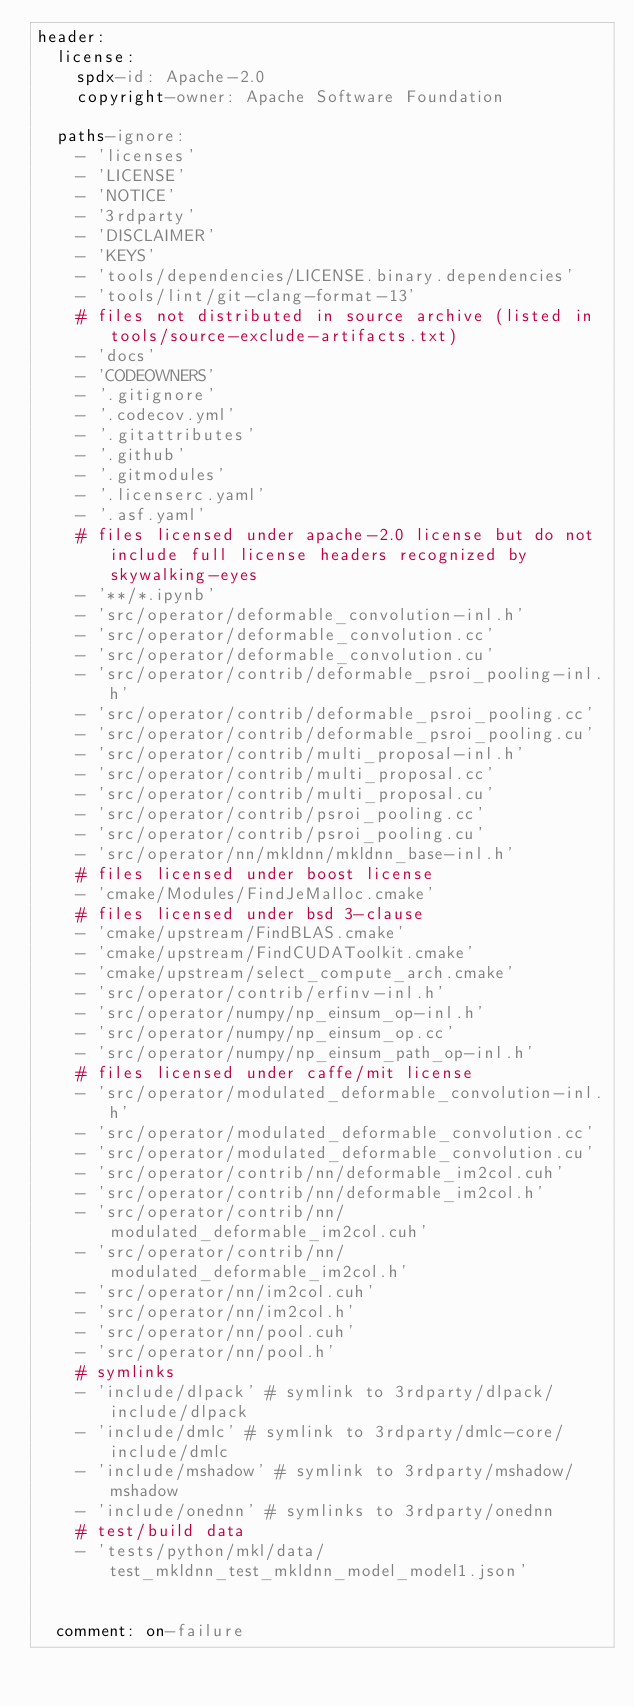<code> <loc_0><loc_0><loc_500><loc_500><_YAML_>header:
  license:
    spdx-id: Apache-2.0
    copyright-owner: Apache Software Foundation

  paths-ignore:
    - 'licenses'
    - 'LICENSE'
    - 'NOTICE'
    - '3rdparty'
    - 'DISCLAIMER'
    - 'KEYS'
    - 'tools/dependencies/LICENSE.binary.dependencies'
    - 'tools/lint/git-clang-format-13'
    # files not distributed in source archive (listed in tools/source-exclude-artifacts.txt)
    - 'docs'
    - 'CODEOWNERS'
    - '.gitignore'
    - '.codecov.yml'
    - '.gitattributes'
    - '.github'
    - '.gitmodules'
    - '.licenserc.yaml'
    - '.asf.yaml'
    # files licensed under apache-2.0 license but do not include full license headers recognized by skywalking-eyes
    - '**/*.ipynb'
    - 'src/operator/deformable_convolution-inl.h'
    - 'src/operator/deformable_convolution.cc'
    - 'src/operator/deformable_convolution.cu'
    - 'src/operator/contrib/deformable_psroi_pooling-inl.h'
    - 'src/operator/contrib/deformable_psroi_pooling.cc'
    - 'src/operator/contrib/deformable_psroi_pooling.cu'
    - 'src/operator/contrib/multi_proposal-inl.h'
    - 'src/operator/contrib/multi_proposal.cc'
    - 'src/operator/contrib/multi_proposal.cu'
    - 'src/operator/contrib/psroi_pooling.cc'
    - 'src/operator/contrib/psroi_pooling.cu'
    - 'src/operator/nn/mkldnn/mkldnn_base-inl.h'
    # files licensed under boost license
    - 'cmake/Modules/FindJeMalloc.cmake'
    # files licensed under bsd 3-clause
    - 'cmake/upstream/FindBLAS.cmake'
    - 'cmake/upstream/FindCUDAToolkit.cmake'
    - 'cmake/upstream/select_compute_arch.cmake'
    - 'src/operator/contrib/erfinv-inl.h'
    - 'src/operator/numpy/np_einsum_op-inl.h'
    - 'src/operator/numpy/np_einsum_op.cc'
    - 'src/operator/numpy/np_einsum_path_op-inl.h'
    # files licensed under caffe/mit license
    - 'src/operator/modulated_deformable_convolution-inl.h'
    - 'src/operator/modulated_deformable_convolution.cc'
    - 'src/operator/modulated_deformable_convolution.cu'
    - 'src/operator/contrib/nn/deformable_im2col.cuh'
    - 'src/operator/contrib/nn/deformable_im2col.h'
    - 'src/operator/contrib/nn/modulated_deformable_im2col.cuh'
    - 'src/operator/contrib/nn/modulated_deformable_im2col.h'
    - 'src/operator/nn/im2col.cuh'
    - 'src/operator/nn/im2col.h'
    - 'src/operator/nn/pool.cuh'
    - 'src/operator/nn/pool.h'
    # symlinks
    - 'include/dlpack' # symlink to 3rdparty/dlpack/include/dlpack
    - 'include/dmlc' # symlink to 3rdparty/dmlc-core/include/dmlc
    - 'include/mshadow' # symlink to 3rdparty/mshadow/mshadow
    - 'include/onednn' # symlinks to 3rdparty/onednn
    # test/build data
    - 'tests/python/mkl/data/test_mkldnn_test_mkldnn_model_model1.json'


  comment: on-failure
</code> 